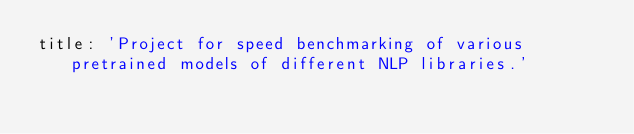<code> <loc_0><loc_0><loc_500><loc_500><_YAML_>title: 'Project for speed benchmarking of various pretrained models of different NLP libraries.'</code> 